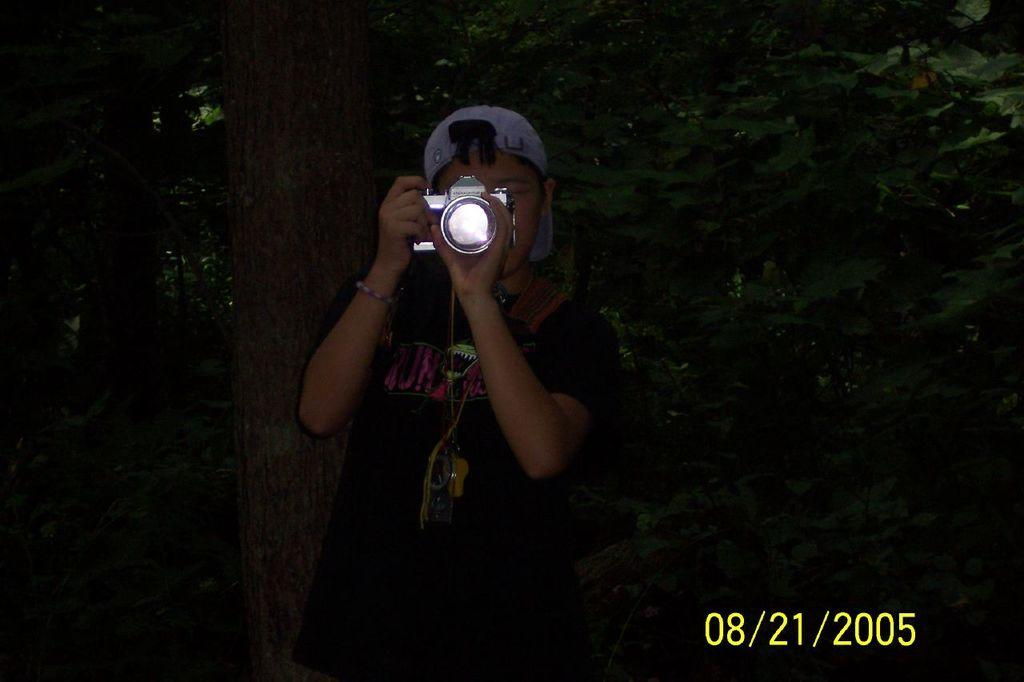Who is the main subject in the image? There is a man in the image. What is the man holding in his hand? The man is holding a camera in his hand. What is the man doing with the camera? The man is taking a photo. What can be seen in the background of the image? There are trees in the background of the image. What type of ball is the man playing with in the image? There is no ball present in the image; the man is holding a camera and taking a photo. 